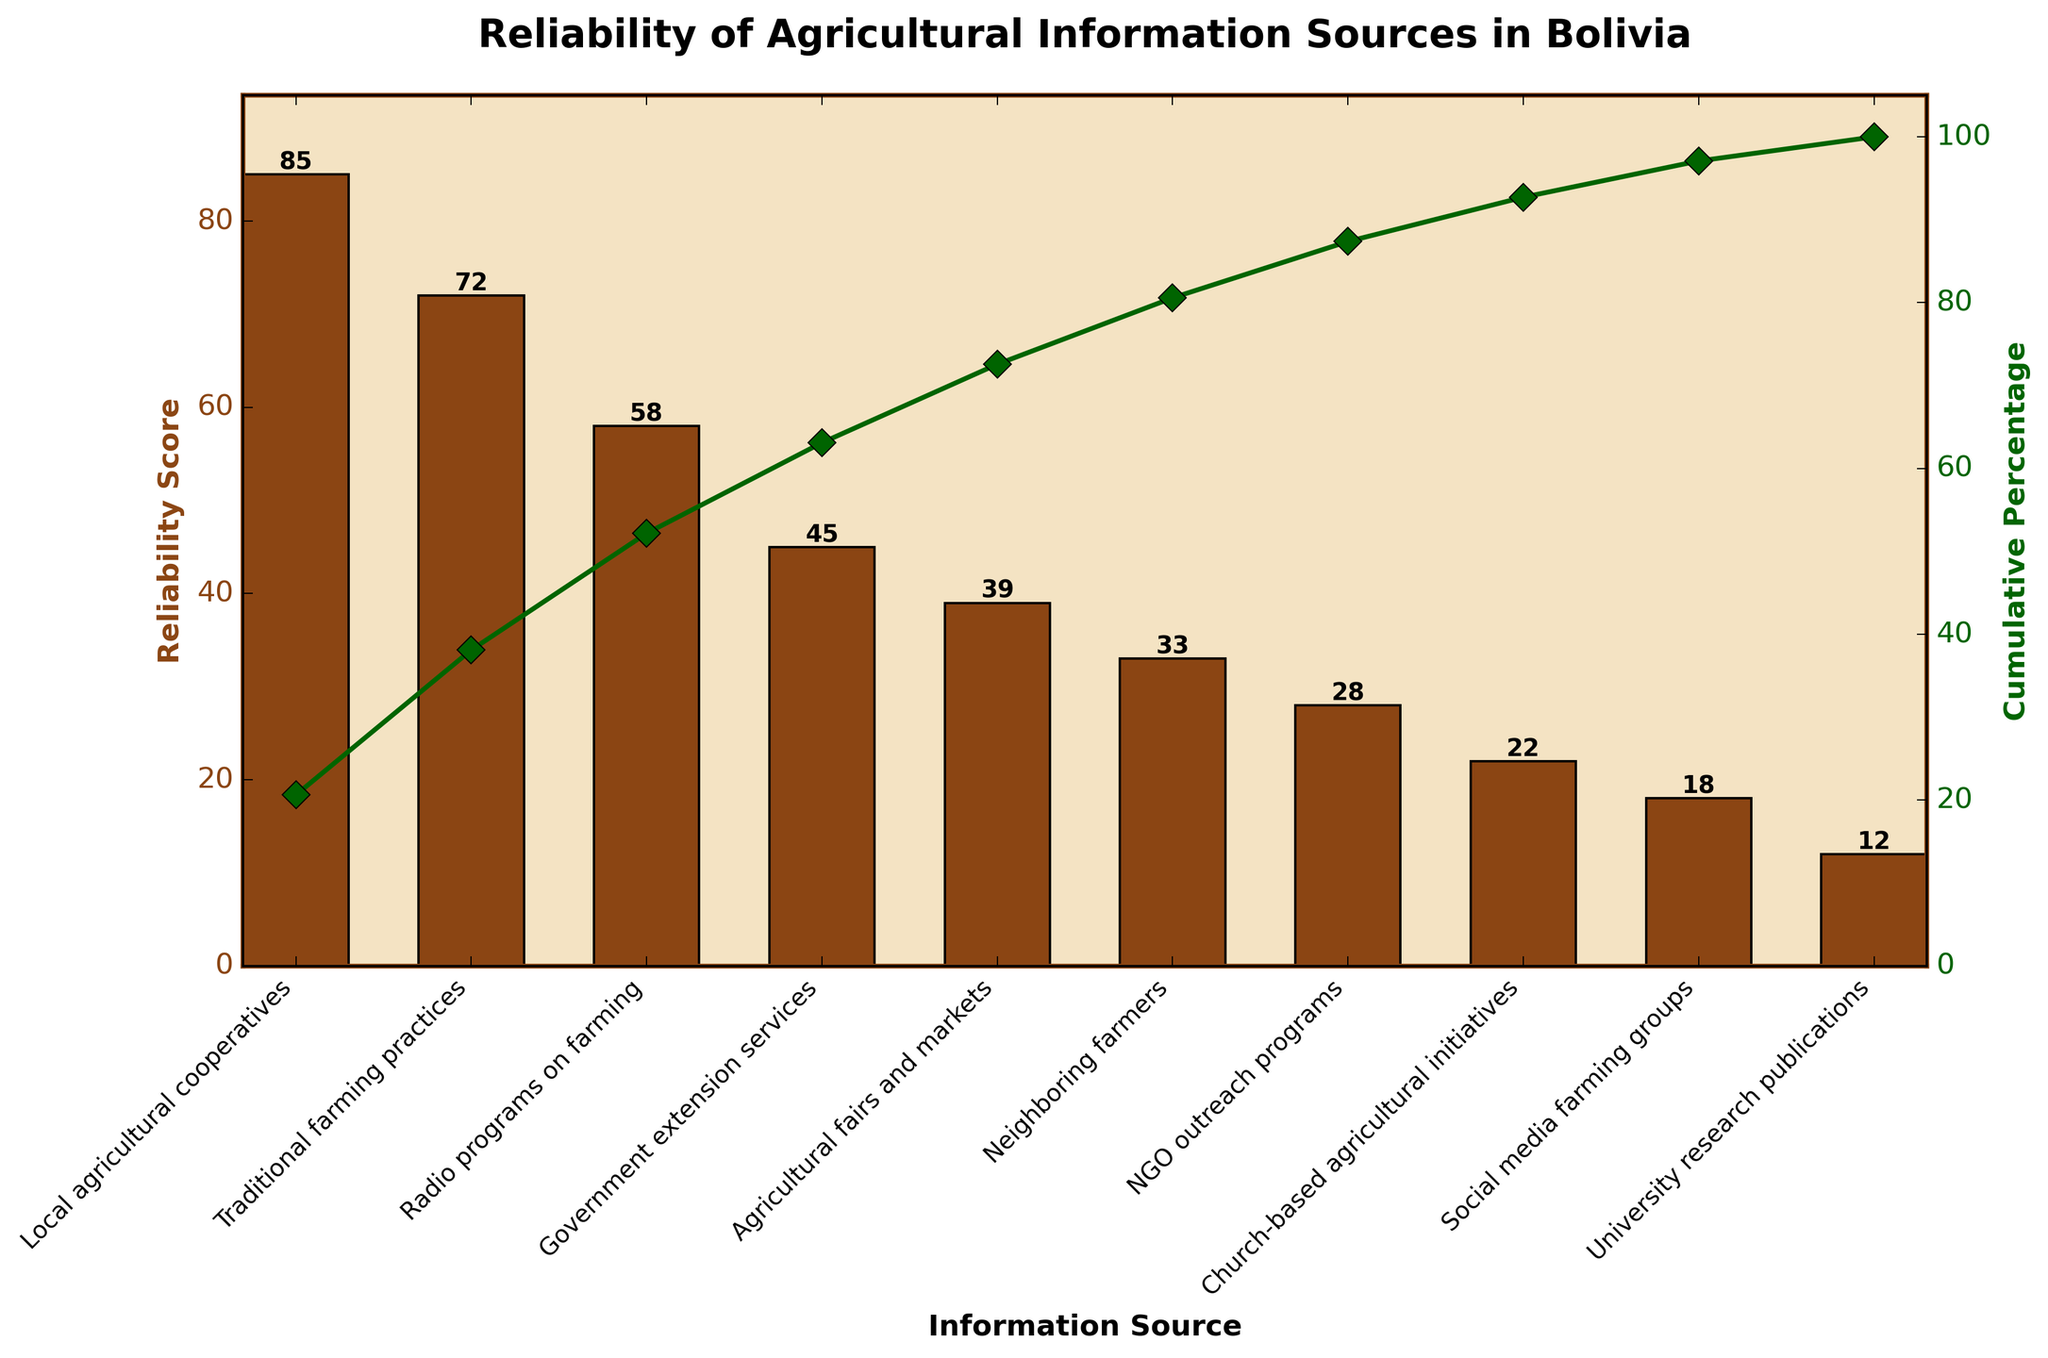What is the title of the figure? The title of the figure is usually found at the top of the plot and it provides a brief description of the content.
Answer: Reliability of Agricultural Information Sources in Bolivia What is the highest reliability score on the chart? The highest reliability score can be determined by looking for the tallest bar on the chart.
Answer: 85 Which information source has the lowest reliability score? To find the source with the lowest score, look for the shortest bar in the chart.
Answer: University research publications What are the reliability scores of "Government extension services" and "Agricultural fairs and markets" combined? Add the reliability scores of the two sources: Government extension services (45) and Agricultural fairs and markets (39). 45 + 39 = 84
Answer: 84 What color is used for plotting the reliability scores? Identify the color used for the bars representing reliability scores.
Answer: Brown How many total information sources are listed in the chart? Count the number of bars or categories on the x-axis.
Answer: 10 What is the reliability score of "Radio programs on farming"? Look for the bar labeled "Radio programs on farming" and note its height in the y-axis.
Answer: 58 What is the cumulative percentage after "Radio programs on farming"? The cumulative percentage can be seen as a line plot and should be noted next to the category "Radio programs on farming".
Answer: 85% Which source has a reliability score that is exactly 18? Identify the bar whose height is 18, noting its label.
Answer: Social media farming groups Is the score for "Traditional farming practices" greater than or less than the score for "Government extension services"? Compare the height of the bars for "Traditional farming practices" (72) and "Government extension services" (45).
Answer: Greater 